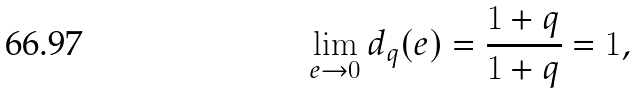Convert formula to latex. <formula><loc_0><loc_0><loc_500><loc_500>\lim _ { e \rightarrow 0 } d _ { q } ( e ) = \frac { 1 + q } { 1 + q } = 1 ,</formula> 